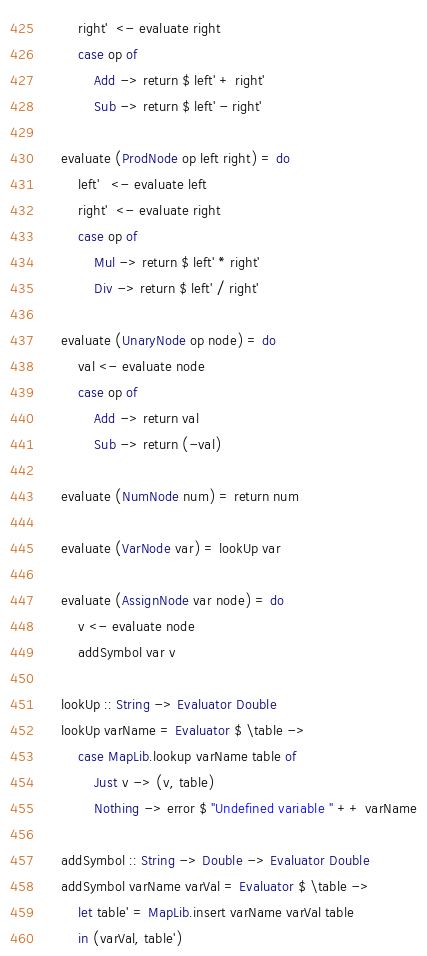<code> <loc_0><loc_0><loc_500><loc_500><_Haskell_>        right'  <- evaluate right
        case op of
            Add -> return $ left' + right'
            Sub -> return $ left' - right'

    evaluate (ProdNode op left right) = do
        left'   <- evaluate left
        right'  <- evaluate right
        case op of
            Mul -> return $ left' * right'
            Div -> return $ left' / right'

    evaluate (UnaryNode op node) = do
        val <- evaluate node
        case op of
            Add -> return val
            Sub -> return (-val)

    evaluate (NumNode num) = return num

    evaluate (VarNode var) = lookUp var

    evaluate (AssignNode var node) = do
        v <- evaluate node
        addSymbol var v

    lookUp :: String -> Evaluator Double
    lookUp varName = Evaluator $ \table ->
        case MapLib.lookup varName table of
            Just v -> (v, table)
            Nothing -> error $ "Undefined variable " ++ varName

    addSymbol :: String -> Double -> Evaluator Double
    addSymbol varName varVal = Evaluator $ \table ->
        let table' = MapLib.insert varName varVal table
        in (varVal, table')
</code> 